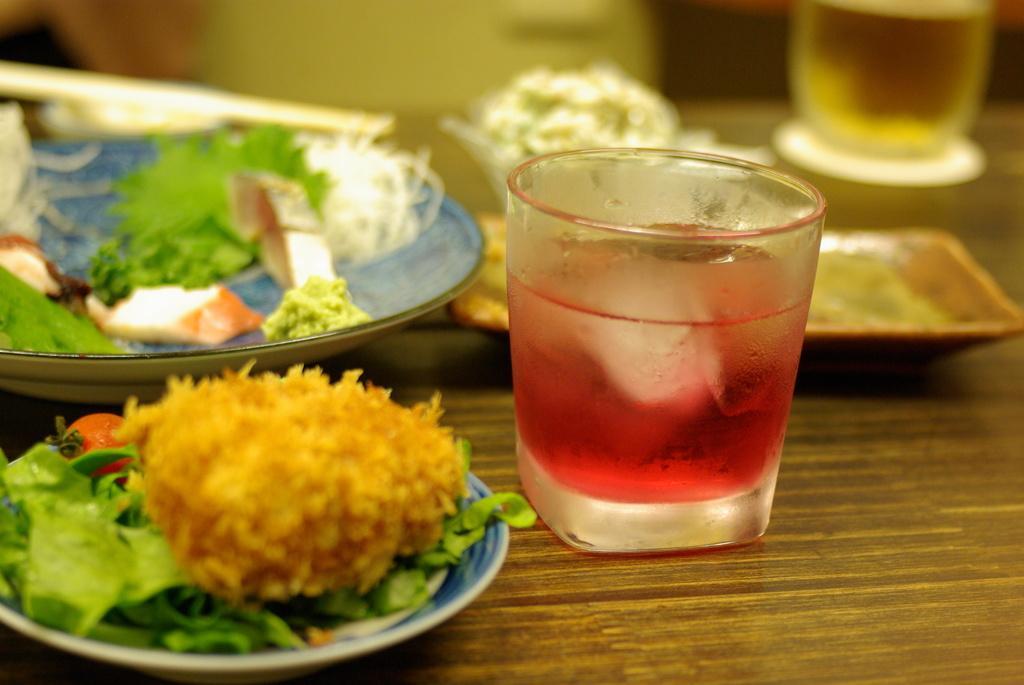Describe this image in one or two sentences. In this picture there is food on the plates and there is drink in the glasses. There are plates and glasses on the table. At the back the image is blurry. 